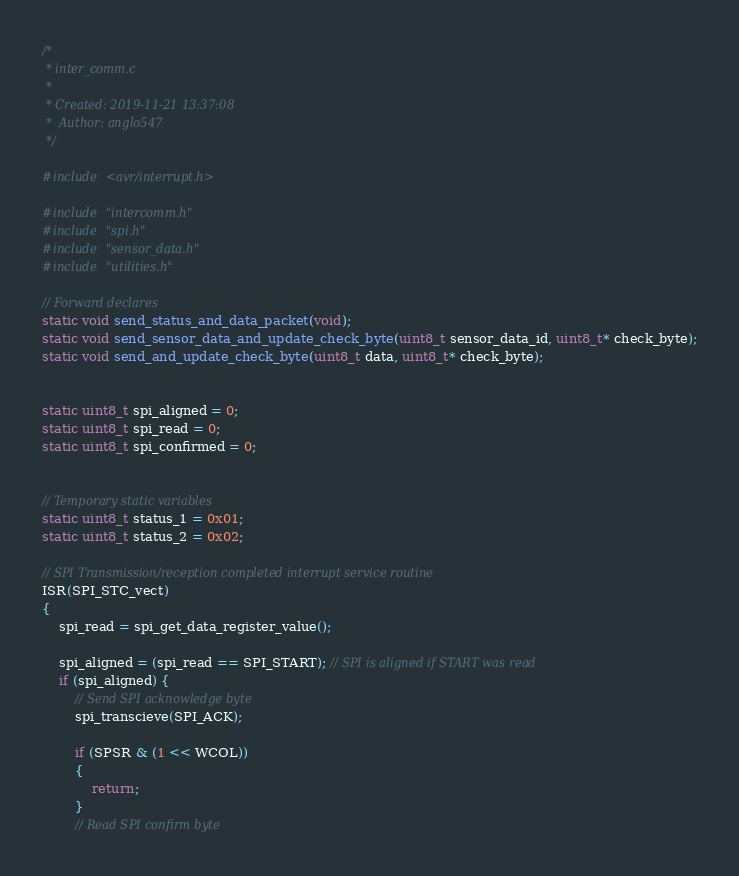Convert code to text. <code><loc_0><loc_0><loc_500><loc_500><_C_>/*
 * inter_comm.c
 *
 * Created: 2019-11-21 13:37:08
 *  Author: anglo547
 */ 

#include <avr/interrupt.h>

#include "intercomm.h"
#include "spi.h"
#include "sensor_data.h"
#include "utilities.h"

// Forward declares
static void send_status_and_data_packet(void);
static void send_sensor_data_and_update_check_byte(uint8_t sensor_data_id, uint8_t* check_byte);
static void send_and_update_check_byte(uint8_t data, uint8_t* check_byte);


static uint8_t spi_aligned = 0;
static uint8_t spi_read = 0;
static uint8_t spi_confirmed = 0;


// Temporary static variables
static uint8_t status_1 = 0x01;
static uint8_t status_2 = 0x02;

// SPI Transmission/reception completed interrupt service routine
ISR(SPI_STC_vect)
{	
	spi_read = spi_get_data_register_value();

	spi_aligned = (spi_read == SPI_START); // SPI is aligned if START was read
	if (spi_aligned) {
		// Send SPI acknowledge byte
		spi_transcieve(SPI_ACK);
		
		if (SPSR & (1 << WCOL))
		{
			return;
		}
		// Read SPI confirm byte</code> 